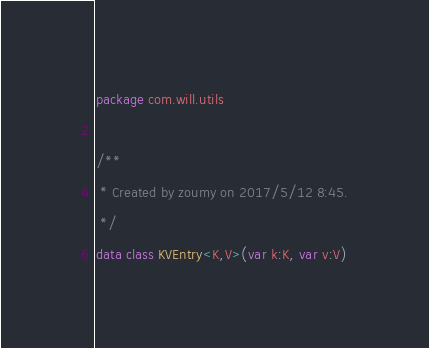Convert code to text. <code><loc_0><loc_0><loc_500><loc_500><_Kotlin_>package com.will.utils

/**
 * Created by zoumy on 2017/5/12 8:45.
 */
data class KVEntry<K,V>(var k:K, var v:V)</code> 